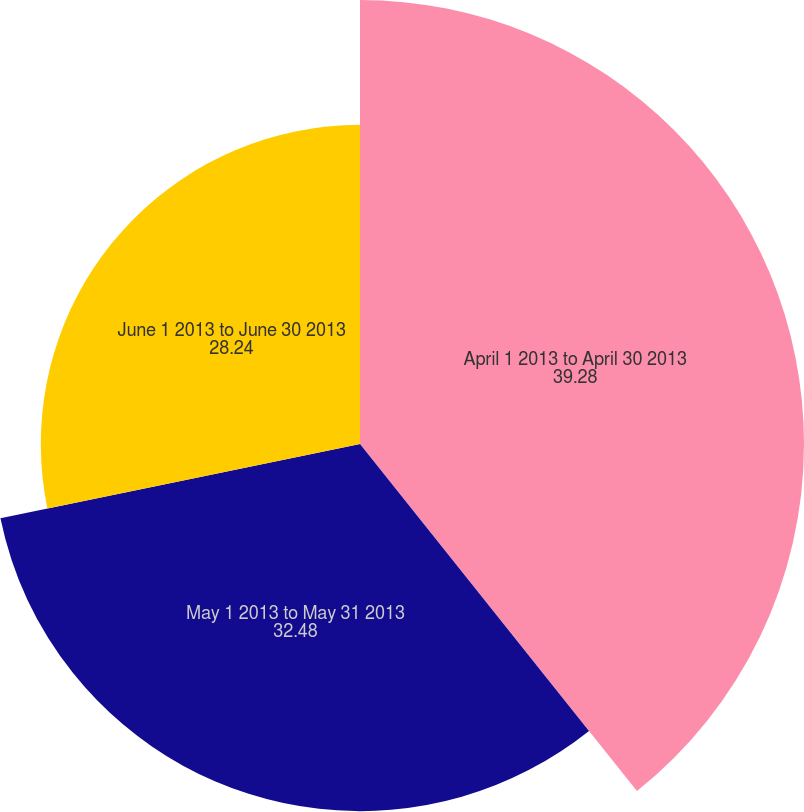<chart> <loc_0><loc_0><loc_500><loc_500><pie_chart><fcel>April 1 2013 to April 30 2013<fcel>May 1 2013 to May 31 2013<fcel>June 1 2013 to June 30 2013<nl><fcel>39.28%<fcel>32.48%<fcel>28.24%<nl></chart> 